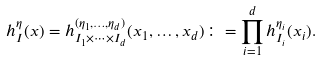Convert formula to latex. <formula><loc_0><loc_0><loc_500><loc_500>h _ { I } ^ { \eta } ( x ) = h _ { I _ { 1 } \times \cdots \times I _ { d } } ^ { ( \eta _ { 1 } , \dots , \eta _ { d } ) } ( x _ { 1 } , \dots , x _ { d } ) \colon = \prod _ { i = 1 } ^ { d } h _ { I _ { i } } ^ { \eta _ { i } } ( x _ { i } ) .</formula> 